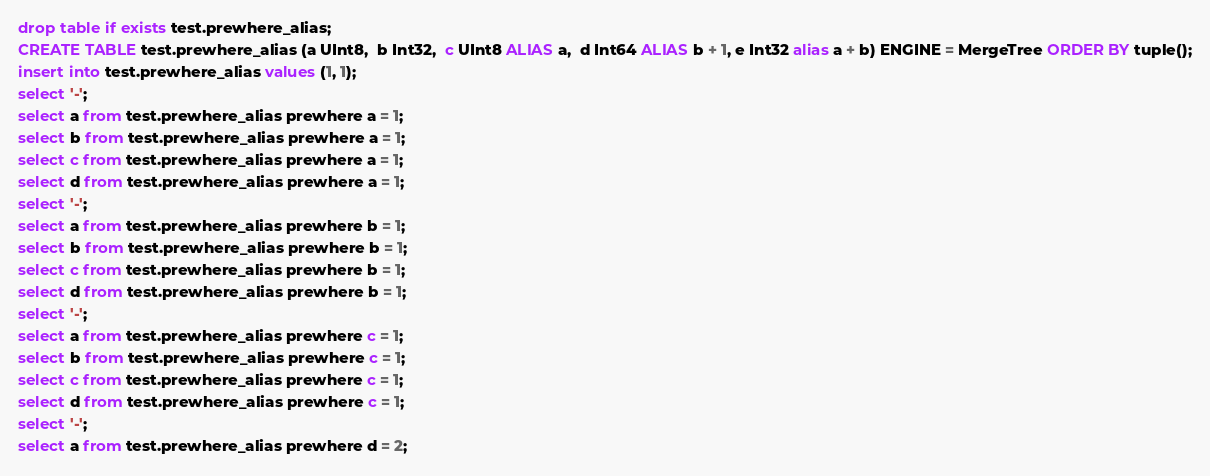Convert code to text. <code><loc_0><loc_0><loc_500><loc_500><_SQL_>drop table if exists test.prewhere_alias;
CREATE TABLE test.prewhere_alias (a UInt8,  b Int32,  c UInt8 ALIAS a,  d Int64 ALIAS b + 1, e Int32 alias a + b) ENGINE = MergeTree ORDER BY tuple();
insert into test.prewhere_alias values (1, 1);
select '-';
select a from test.prewhere_alias prewhere a = 1;
select b from test.prewhere_alias prewhere a = 1;
select c from test.prewhere_alias prewhere a = 1;
select d from test.prewhere_alias prewhere a = 1;
select '-';
select a from test.prewhere_alias prewhere b = 1;
select b from test.prewhere_alias prewhere b = 1;
select c from test.prewhere_alias prewhere b = 1;
select d from test.prewhere_alias prewhere b = 1;
select '-';
select a from test.prewhere_alias prewhere c = 1;
select b from test.prewhere_alias prewhere c = 1;
select c from test.prewhere_alias prewhere c = 1;
select d from test.prewhere_alias prewhere c = 1;
select '-';
select a from test.prewhere_alias prewhere d = 2;</code> 